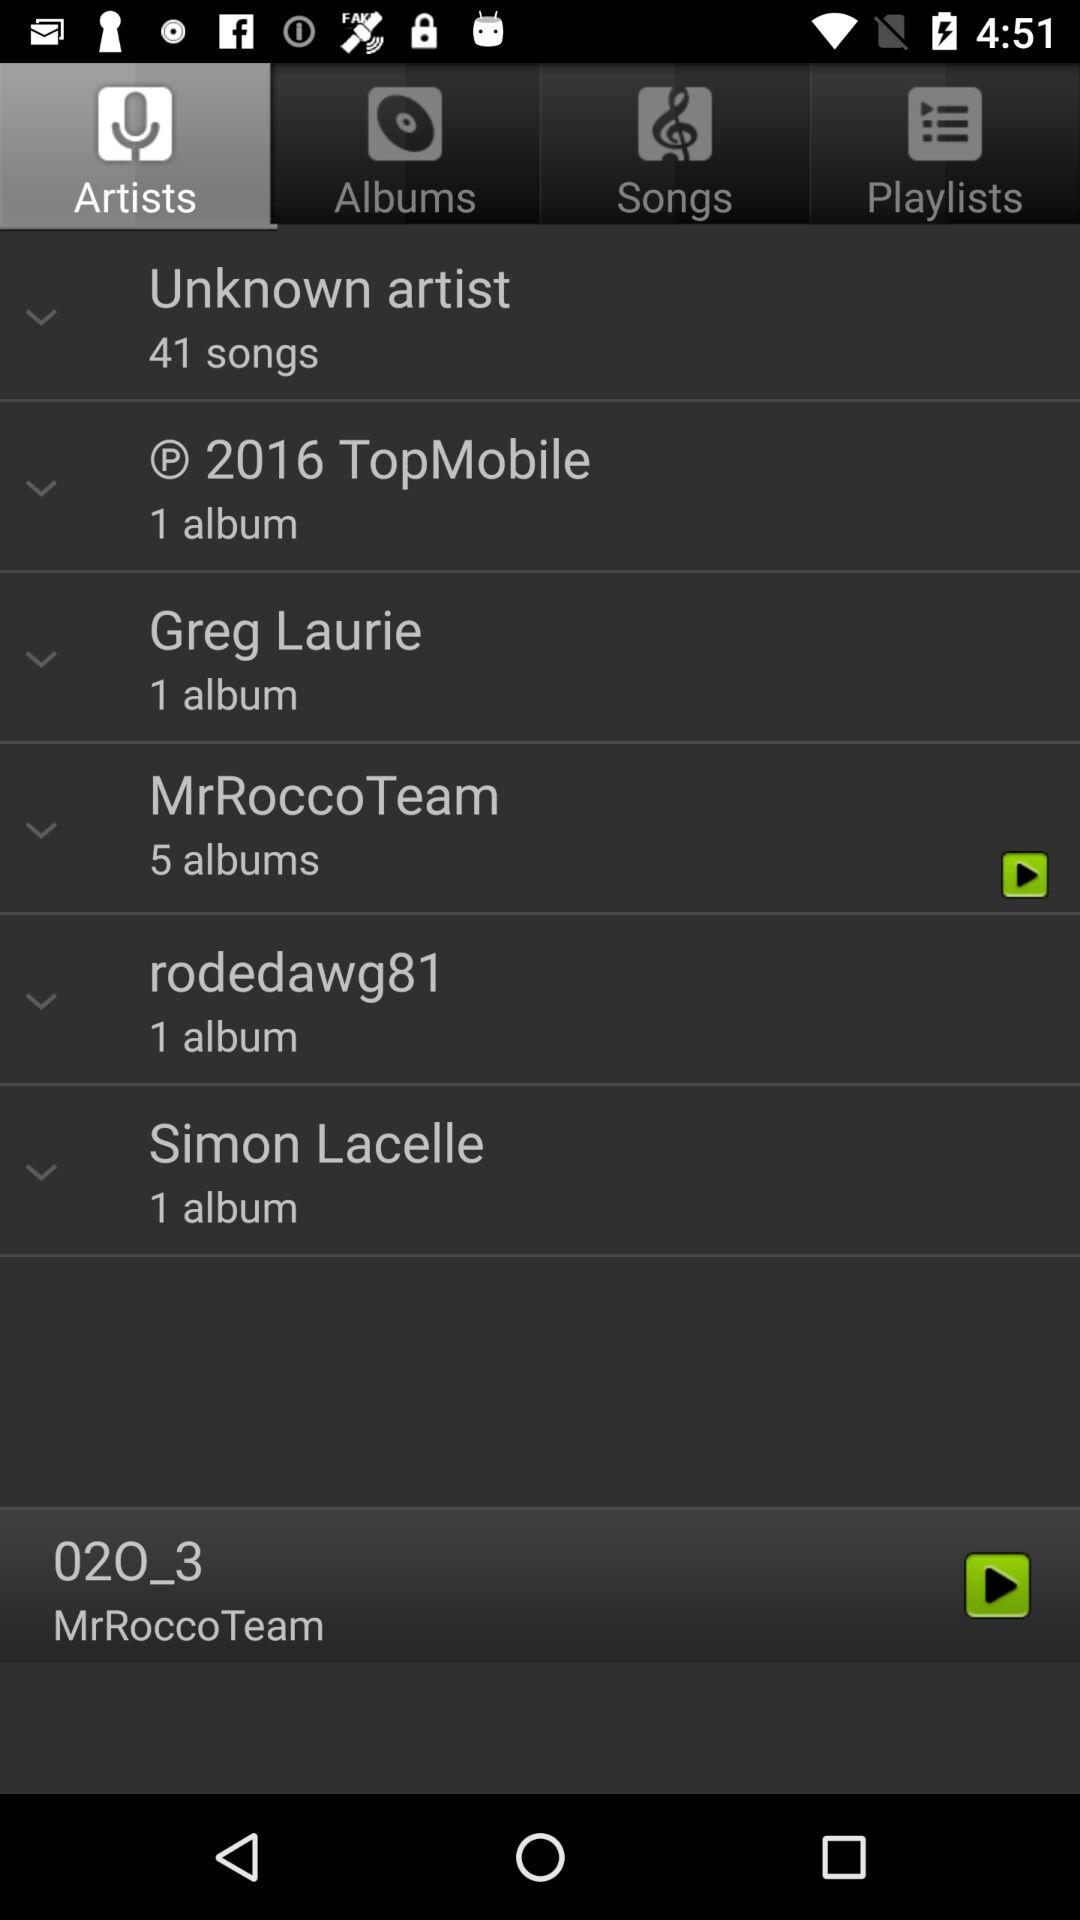How many albums are there by Greg Laurie? There is 1 album. 